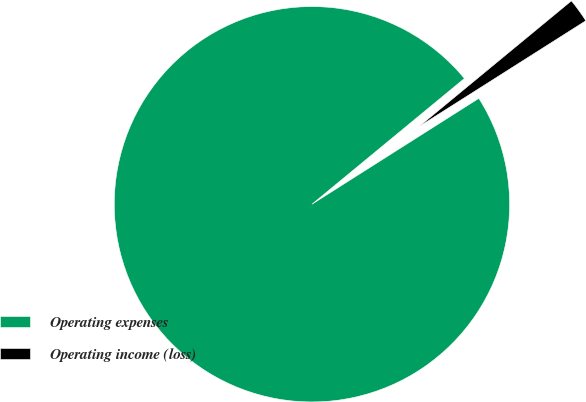<chart> <loc_0><loc_0><loc_500><loc_500><pie_chart><fcel>Operating expenses<fcel>Operating income (loss)<nl><fcel>98.02%<fcel>1.98%<nl></chart> 